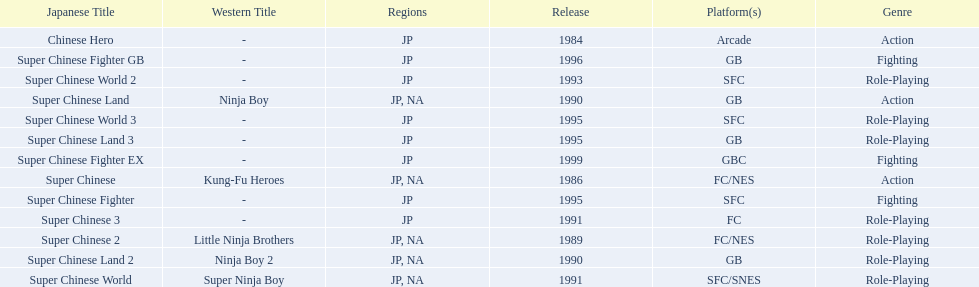What japanese titles were released in the north american (na) region? Super Chinese, Super Chinese 2, Super Chinese Land, Super Chinese Land 2, Super Chinese World. Of those, which one was released most recently? Super Chinese World. 